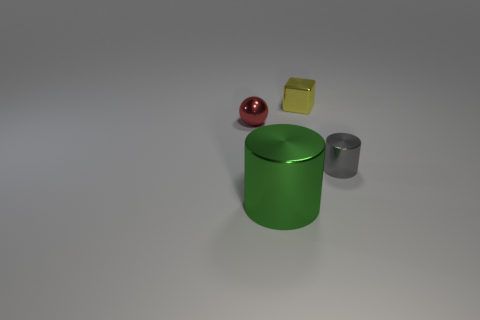Do the tiny shiny object in front of the metallic ball and the object in front of the gray thing have the same shape?
Offer a very short reply. Yes. There is a metallic object that is in front of the cylinder that is behind the metallic cylinder that is to the left of the small gray metallic cylinder; what is its color?
Keep it short and to the point. Green. There is a cylinder that is to the left of the small gray metallic object; what color is it?
Offer a very short reply. Green. What color is the cylinder that is the same size as the red object?
Ensure brevity in your answer.  Gray. Do the green object and the ball have the same size?
Ensure brevity in your answer.  No. How many metallic things are left of the small gray metallic cylinder?
Your answer should be compact. 3. How many objects are small metallic things right of the green metallic thing or red metallic balls?
Provide a short and direct response. 3. Is the number of objects to the right of the small red ball greater than the number of red metallic spheres left of the small metallic cube?
Give a very brief answer. Yes. Is the size of the gray object the same as the shiny sphere left of the green cylinder?
Ensure brevity in your answer.  Yes. What number of balls are either tiny yellow metallic objects or big metallic objects?
Your answer should be compact. 0. 